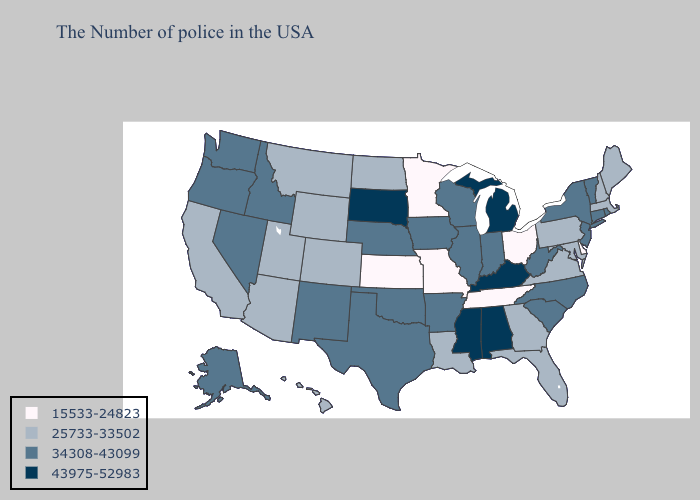Does the first symbol in the legend represent the smallest category?
Quick response, please. Yes. Which states have the lowest value in the Northeast?
Concise answer only. Maine, Massachusetts, New Hampshire, Pennsylvania. Does Maine have the highest value in the Northeast?
Quick response, please. No. Name the states that have a value in the range 15533-24823?
Keep it brief. Delaware, Ohio, Tennessee, Missouri, Minnesota, Kansas. Is the legend a continuous bar?
Quick response, please. No. Among the states that border Rhode Island , which have the highest value?
Quick response, please. Connecticut. How many symbols are there in the legend?
Short answer required. 4. What is the highest value in the USA?
Give a very brief answer. 43975-52983. What is the lowest value in states that border Louisiana?
Concise answer only. 34308-43099. Does Montana have a higher value than Tennessee?
Answer briefly. Yes. What is the highest value in states that border Florida?
Short answer required. 43975-52983. What is the value of Massachusetts?
Keep it brief. 25733-33502. Does Alaska have the lowest value in the West?
Short answer required. No. Does West Virginia have a higher value than Ohio?
Concise answer only. Yes. What is the value of New York?
Concise answer only. 34308-43099. 